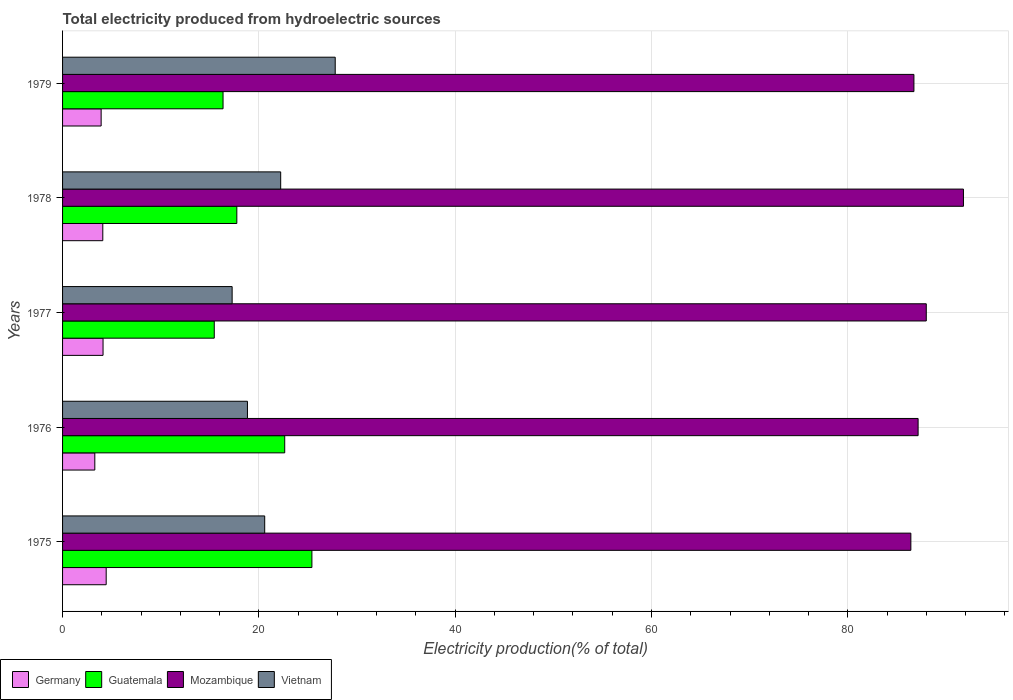Are the number of bars per tick equal to the number of legend labels?
Make the answer very short. Yes. What is the label of the 2nd group of bars from the top?
Offer a very short reply. 1978. What is the total electricity produced in Vietnam in 1975?
Keep it short and to the point. 20.59. Across all years, what is the maximum total electricity produced in Mozambique?
Provide a short and direct response. 91.78. Across all years, what is the minimum total electricity produced in Mozambique?
Give a very brief answer. 86.42. In which year was the total electricity produced in Guatemala maximum?
Offer a very short reply. 1975. In which year was the total electricity produced in Mozambique minimum?
Provide a succinct answer. 1975. What is the total total electricity produced in Vietnam in the graph?
Keep it short and to the point. 106.71. What is the difference between the total electricity produced in Vietnam in 1975 and that in 1978?
Keep it short and to the point. -1.63. What is the difference between the total electricity produced in Vietnam in 1978 and the total electricity produced in Guatemala in 1976?
Your answer should be very brief. -0.41. What is the average total electricity produced in Vietnam per year?
Your answer should be compact. 21.34. In the year 1977, what is the difference between the total electricity produced in Mozambique and total electricity produced in Guatemala?
Your response must be concise. 72.54. In how many years, is the total electricity produced in Mozambique greater than 88 %?
Ensure brevity in your answer.  1. What is the ratio of the total electricity produced in Germany in 1976 to that in 1978?
Keep it short and to the point. 0.8. Is the total electricity produced in Mozambique in 1975 less than that in 1976?
Your response must be concise. Yes. Is the difference between the total electricity produced in Mozambique in 1976 and 1978 greater than the difference between the total electricity produced in Guatemala in 1976 and 1978?
Make the answer very short. No. What is the difference between the highest and the second highest total electricity produced in Mozambique?
Offer a very short reply. 3.79. What is the difference between the highest and the lowest total electricity produced in Germany?
Offer a terse response. 1.16. Is the sum of the total electricity produced in Mozambique in 1976 and 1978 greater than the maximum total electricity produced in Vietnam across all years?
Ensure brevity in your answer.  Yes. What does the 1st bar from the top in 1977 represents?
Your answer should be compact. Vietnam. What does the 3rd bar from the bottom in 1978 represents?
Your answer should be very brief. Mozambique. Is it the case that in every year, the sum of the total electricity produced in Guatemala and total electricity produced in Vietnam is greater than the total electricity produced in Germany?
Your answer should be compact. Yes. How many bars are there?
Keep it short and to the point. 20. Are all the bars in the graph horizontal?
Provide a short and direct response. Yes. What is the difference between two consecutive major ticks on the X-axis?
Give a very brief answer. 20. Does the graph contain grids?
Offer a very short reply. Yes. How are the legend labels stacked?
Offer a very short reply. Horizontal. What is the title of the graph?
Your answer should be very brief. Total electricity produced from hydroelectric sources. What is the label or title of the X-axis?
Give a very brief answer. Electricity production(% of total). What is the Electricity production(% of total) in Germany in 1975?
Keep it short and to the point. 4.44. What is the Electricity production(% of total) of Guatemala in 1975?
Ensure brevity in your answer.  25.4. What is the Electricity production(% of total) of Mozambique in 1975?
Your answer should be compact. 86.42. What is the Electricity production(% of total) in Vietnam in 1975?
Keep it short and to the point. 20.59. What is the Electricity production(% of total) in Germany in 1976?
Ensure brevity in your answer.  3.29. What is the Electricity production(% of total) of Guatemala in 1976?
Keep it short and to the point. 22.63. What is the Electricity production(% of total) in Mozambique in 1976?
Your response must be concise. 87.16. What is the Electricity production(% of total) of Vietnam in 1976?
Provide a succinct answer. 18.84. What is the Electricity production(% of total) in Germany in 1977?
Your answer should be very brief. 4.12. What is the Electricity production(% of total) of Guatemala in 1977?
Provide a short and direct response. 15.46. What is the Electricity production(% of total) of Mozambique in 1977?
Provide a succinct answer. 87.99. What is the Electricity production(% of total) in Vietnam in 1977?
Provide a short and direct response. 17.28. What is the Electricity production(% of total) of Germany in 1978?
Provide a short and direct response. 4.1. What is the Electricity production(% of total) in Guatemala in 1978?
Provide a succinct answer. 17.75. What is the Electricity production(% of total) of Mozambique in 1978?
Give a very brief answer. 91.78. What is the Electricity production(% of total) in Vietnam in 1978?
Ensure brevity in your answer.  22.22. What is the Electricity production(% of total) of Germany in 1979?
Ensure brevity in your answer.  3.93. What is the Electricity production(% of total) of Guatemala in 1979?
Provide a succinct answer. 16.35. What is the Electricity production(% of total) of Mozambique in 1979?
Provide a succinct answer. 86.73. What is the Electricity production(% of total) in Vietnam in 1979?
Ensure brevity in your answer.  27.78. Across all years, what is the maximum Electricity production(% of total) in Germany?
Ensure brevity in your answer.  4.44. Across all years, what is the maximum Electricity production(% of total) in Guatemala?
Make the answer very short. 25.4. Across all years, what is the maximum Electricity production(% of total) of Mozambique?
Your answer should be very brief. 91.78. Across all years, what is the maximum Electricity production(% of total) of Vietnam?
Provide a short and direct response. 27.78. Across all years, what is the minimum Electricity production(% of total) of Germany?
Your answer should be compact. 3.29. Across all years, what is the minimum Electricity production(% of total) in Guatemala?
Your response must be concise. 15.46. Across all years, what is the minimum Electricity production(% of total) in Mozambique?
Keep it short and to the point. 86.42. Across all years, what is the minimum Electricity production(% of total) in Vietnam?
Ensure brevity in your answer.  17.28. What is the total Electricity production(% of total) in Germany in the graph?
Your answer should be very brief. 19.88. What is the total Electricity production(% of total) of Guatemala in the graph?
Provide a succinct answer. 97.59. What is the total Electricity production(% of total) of Mozambique in the graph?
Your answer should be very brief. 440.09. What is the total Electricity production(% of total) of Vietnam in the graph?
Make the answer very short. 106.71. What is the difference between the Electricity production(% of total) in Germany in 1975 and that in 1976?
Your answer should be very brief. 1.16. What is the difference between the Electricity production(% of total) of Guatemala in 1975 and that in 1976?
Ensure brevity in your answer.  2.77. What is the difference between the Electricity production(% of total) of Mozambique in 1975 and that in 1976?
Ensure brevity in your answer.  -0.74. What is the difference between the Electricity production(% of total) of Vietnam in 1975 and that in 1976?
Keep it short and to the point. 1.76. What is the difference between the Electricity production(% of total) of Germany in 1975 and that in 1977?
Give a very brief answer. 0.32. What is the difference between the Electricity production(% of total) in Guatemala in 1975 and that in 1977?
Offer a very short reply. 9.95. What is the difference between the Electricity production(% of total) in Mozambique in 1975 and that in 1977?
Offer a terse response. -1.57. What is the difference between the Electricity production(% of total) in Vietnam in 1975 and that in 1977?
Offer a very short reply. 3.32. What is the difference between the Electricity production(% of total) of Germany in 1975 and that in 1978?
Offer a terse response. 0.35. What is the difference between the Electricity production(% of total) of Guatemala in 1975 and that in 1978?
Ensure brevity in your answer.  7.65. What is the difference between the Electricity production(% of total) of Mozambique in 1975 and that in 1978?
Offer a very short reply. -5.36. What is the difference between the Electricity production(% of total) of Vietnam in 1975 and that in 1978?
Your answer should be compact. -1.63. What is the difference between the Electricity production(% of total) of Germany in 1975 and that in 1979?
Give a very brief answer. 0.51. What is the difference between the Electricity production(% of total) of Guatemala in 1975 and that in 1979?
Make the answer very short. 9.05. What is the difference between the Electricity production(% of total) in Mozambique in 1975 and that in 1979?
Make the answer very short. -0.31. What is the difference between the Electricity production(% of total) in Vietnam in 1975 and that in 1979?
Give a very brief answer. -7.18. What is the difference between the Electricity production(% of total) of Germany in 1976 and that in 1977?
Offer a terse response. -0.84. What is the difference between the Electricity production(% of total) of Guatemala in 1976 and that in 1977?
Make the answer very short. 7.18. What is the difference between the Electricity production(% of total) in Mozambique in 1976 and that in 1977?
Provide a succinct answer. -0.83. What is the difference between the Electricity production(% of total) of Vietnam in 1976 and that in 1977?
Ensure brevity in your answer.  1.56. What is the difference between the Electricity production(% of total) of Germany in 1976 and that in 1978?
Offer a very short reply. -0.81. What is the difference between the Electricity production(% of total) of Guatemala in 1976 and that in 1978?
Keep it short and to the point. 4.88. What is the difference between the Electricity production(% of total) of Mozambique in 1976 and that in 1978?
Ensure brevity in your answer.  -4.62. What is the difference between the Electricity production(% of total) of Vietnam in 1976 and that in 1978?
Your answer should be compact. -3.39. What is the difference between the Electricity production(% of total) in Germany in 1976 and that in 1979?
Provide a succinct answer. -0.64. What is the difference between the Electricity production(% of total) of Guatemala in 1976 and that in 1979?
Your answer should be compact. 6.28. What is the difference between the Electricity production(% of total) in Mozambique in 1976 and that in 1979?
Make the answer very short. 0.43. What is the difference between the Electricity production(% of total) of Vietnam in 1976 and that in 1979?
Ensure brevity in your answer.  -8.94. What is the difference between the Electricity production(% of total) of Germany in 1977 and that in 1978?
Your answer should be very brief. 0.03. What is the difference between the Electricity production(% of total) of Guatemala in 1977 and that in 1978?
Provide a succinct answer. -2.3. What is the difference between the Electricity production(% of total) in Mozambique in 1977 and that in 1978?
Keep it short and to the point. -3.79. What is the difference between the Electricity production(% of total) in Vietnam in 1977 and that in 1978?
Ensure brevity in your answer.  -4.95. What is the difference between the Electricity production(% of total) in Germany in 1977 and that in 1979?
Offer a very short reply. 0.19. What is the difference between the Electricity production(% of total) of Guatemala in 1977 and that in 1979?
Provide a succinct answer. -0.89. What is the difference between the Electricity production(% of total) in Mozambique in 1977 and that in 1979?
Give a very brief answer. 1.26. What is the difference between the Electricity production(% of total) in Vietnam in 1977 and that in 1979?
Your answer should be compact. -10.5. What is the difference between the Electricity production(% of total) in Germany in 1978 and that in 1979?
Your answer should be compact. 0.17. What is the difference between the Electricity production(% of total) of Guatemala in 1978 and that in 1979?
Provide a short and direct response. 1.4. What is the difference between the Electricity production(% of total) in Mozambique in 1978 and that in 1979?
Your answer should be compact. 5.05. What is the difference between the Electricity production(% of total) in Vietnam in 1978 and that in 1979?
Offer a very short reply. -5.56. What is the difference between the Electricity production(% of total) in Germany in 1975 and the Electricity production(% of total) in Guatemala in 1976?
Make the answer very short. -18.19. What is the difference between the Electricity production(% of total) in Germany in 1975 and the Electricity production(% of total) in Mozambique in 1976?
Your answer should be very brief. -82.72. What is the difference between the Electricity production(% of total) of Germany in 1975 and the Electricity production(% of total) of Vietnam in 1976?
Offer a terse response. -14.39. What is the difference between the Electricity production(% of total) in Guatemala in 1975 and the Electricity production(% of total) in Mozambique in 1976?
Offer a very short reply. -61.76. What is the difference between the Electricity production(% of total) of Guatemala in 1975 and the Electricity production(% of total) of Vietnam in 1976?
Provide a succinct answer. 6.57. What is the difference between the Electricity production(% of total) in Mozambique in 1975 and the Electricity production(% of total) in Vietnam in 1976?
Your response must be concise. 67.59. What is the difference between the Electricity production(% of total) of Germany in 1975 and the Electricity production(% of total) of Guatemala in 1977?
Offer a terse response. -11.01. What is the difference between the Electricity production(% of total) in Germany in 1975 and the Electricity production(% of total) in Mozambique in 1977?
Offer a very short reply. -83.55. What is the difference between the Electricity production(% of total) of Germany in 1975 and the Electricity production(% of total) of Vietnam in 1977?
Your answer should be compact. -12.83. What is the difference between the Electricity production(% of total) of Guatemala in 1975 and the Electricity production(% of total) of Mozambique in 1977?
Make the answer very short. -62.59. What is the difference between the Electricity production(% of total) of Guatemala in 1975 and the Electricity production(% of total) of Vietnam in 1977?
Your answer should be very brief. 8.13. What is the difference between the Electricity production(% of total) of Mozambique in 1975 and the Electricity production(% of total) of Vietnam in 1977?
Make the answer very short. 69.15. What is the difference between the Electricity production(% of total) of Germany in 1975 and the Electricity production(% of total) of Guatemala in 1978?
Offer a terse response. -13.31. What is the difference between the Electricity production(% of total) in Germany in 1975 and the Electricity production(% of total) in Mozambique in 1978?
Provide a short and direct response. -87.34. What is the difference between the Electricity production(% of total) of Germany in 1975 and the Electricity production(% of total) of Vietnam in 1978?
Make the answer very short. -17.78. What is the difference between the Electricity production(% of total) of Guatemala in 1975 and the Electricity production(% of total) of Mozambique in 1978?
Make the answer very short. -66.38. What is the difference between the Electricity production(% of total) in Guatemala in 1975 and the Electricity production(% of total) in Vietnam in 1978?
Ensure brevity in your answer.  3.18. What is the difference between the Electricity production(% of total) in Mozambique in 1975 and the Electricity production(% of total) in Vietnam in 1978?
Provide a short and direct response. 64.2. What is the difference between the Electricity production(% of total) of Germany in 1975 and the Electricity production(% of total) of Guatemala in 1979?
Give a very brief answer. -11.91. What is the difference between the Electricity production(% of total) in Germany in 1975 and the Electricity production(% of total) in Mozambique in 1979?
Ensure brevity in your answer.  -82.29. What is the difference between the Electricity production(% of total) in Germany in 1975 and the Electricity production(% of total) in Vietnam in 1979?
Offer a terse response. -23.33. What is the difference between the Electricity production(% of total) in Guatemala in 1975 and the Electricity production(% of total) in Mozambique in 1979?
Your answer should be very brief. -61.33. What is the difference between the Electricity production(% of total) of Guatemala in 1975 and the Electricity production(% of total) of Vietnam in 1979?
Provide a succinct answer. -2.38. What is the difference between the Electricity production(% of total) of Mozambique in 1975 and the Electricity production(% of total) of Vietnam in 1979?
Provide a succinct answer. 58.65. What is the difference between the Electricity production(% of total) in Germany in 1976 and the Electricity production(% of total) in Guatemala in 1977?
Your answer should be very brief. -12.17. What is the difference between the Electricity production(% of total) in Germany in 1976 and the Electricity production(% of total) in Mozambique in 1977?
Ensure brevity in your answer.  -84.71. What is the difference between the Electricity production(% of total) in Germany in 1976 and the Electricity production(% of total) in Vietnam in 1977?
Give a very brief answer. -13.99. What is the difference between the Electricity production(% of total) in Guatemala in 1976 and the Electricity production(% of total) in Mozambique in 1977?
Provide a short and direct response. -65.36. What is the difference between the Electricity production(% of total) in Guatemala in 1976 and the Electricity production(% of total) in Vietnam in 1977?
Keep it short and to the point. 5.36. What is the difference between the Electricity production(% of total) of Mozambique in 1976 and the Electricity production(% of total) of Vietnam in 1977?
Offer a terse response. 69.89. What is the difference between the Electricity production(% of total) of Germany in 1976 and the Electricity production(% of total) of Guatemala in 1978?
Provide a short and direct response. -14.47. What is the difference between the Electricity production(% of total) of Germany in 1976 and the Electricity production(% of total) of Mozambique in 1978?
Provide a short and direct response. -88.49. What is the difference between the Electricity production(% of total) of Germany in 1976 and the Electricity production(% of total) of Vietnam in 1978?
Make the answer very short. -18.94. What is the difference between the Electricity production(% of total) of Guatemala in 1976 and the Electricity production(% of total) of Mozambique in 1978?
Give a very brief answer. -69.15. What is the difference between the Electricity production(% of total) of Guatemala in 1976 and the Electricity production(% of total) of Vietnam in 1978?
Keep it short and to the point. 0.41. What is the difference between the Electricity production(% of total) in Mozambique in 1976 and the Electricity production(% of total) in Vietnam in 1978?
Give a very brief answer. 64.94. What is the difference between the Electricity production(% of total) of Germany in 1976 and the Electricity production(% of total) of Guatemala in 1979?
Provide a short and direct response. -13.06. What is the difference between the Electricity production(% of total) of Germany in 1976 and the Electricity production(% of total) of Mozambique in 1979?
Provide a succinct answer. -83.45. What is the difference between the Electricity production(% of total) in Germany in 1976 and the Electricity production(% of total) in Vietnam in 1979?
Offer a very short reply. -24.49. What is the difference between the Electricity production(% of total) in Guatemala in 1976 and the Electricity production(% of total) in Mozambique in 1979?
Keep it short and to the point. -64.1. What is the difference between the Electricity production(% of total) of Guatemala in 1976 and the Electricity production(% of total) of Vietnam in 1979?
Make the answer very short. -5.15. What is the difference between the Electricity production(% of total) in Mozambique in 1976 and the Electricity production(% of total) in Vietnam in 1979?
Make the answer very short. 59.38. What is the difference between the Electricity production(% of total) in Germany in 1977 and the Electricity production(% of total) in Guatemala in 1978?
Provide a short and direct response. -13.63. What is the difference between the Electricity production(% of total) of Germany in 1977 and the Electricity production(% of total) of Mozambique in 1978?
Make the answer very short. -87.66. What is the difference between the Electricity production(% of total) in Germany in 1977 and the Electricity production(% of total) in Vietnam in 1978?
Make the answer very short. -18.1. What is the difference between the Electricity production(% of total) in Guatemala in 1977 and the Electricity production(% of total) in Mozambique in 1978?
Keep it short and to the point. -76.33. What is the difference between the Electricity production(% of total) of Guatemala in 1977 and the Electricity production(% of total) of Vietnam in 1978?
Provide a short and direct response. -6.77. What is the difference between the Electricity production(% of total) of Mozambique in 1977 and the Electricity production(% of total) of Vietnam in 1978?
Give a very brief answer. 65.77. What is the difference between the Electricity production(% of total) of Germany in 1977 and the Electricity production(% of total) of Guatemala in 1979?
Your answer should be compact. -12.22. What is the difference between the Electricity production(% of total) in Germany in 1977 and the Electricity production(% of total) in Mozambique in 1979?
Make the answer very short. -82.61. What is the difference between the Electricity production(% of total) of Germany in 1977 and the Electricity production(% of total) of Vietnam in 1979?
Offer a very short reply. -23.65. What is the difference between the Electricity production(% of total) of Guatemala in 1977 and the Electricity production(% of total) of Mozambique in 1979?
Keep it short and to the point. -71.28. What is the difference between the Electricity production(% of total) in Guatemala in 1977 and the Electricity production(% of total) in Vietnam in 1979?
Ensure brevity in your answer.  -12.32. What is the difference between the Electricity production(% of total) of Mozambique in 1977 and the Electricity production(% of total) of Vietnam in 1979?
Your answer should be compact. 60.22. What is the difference between the Electricity production(% of total) of Germany in 1978 and the Electricity production(% of total) of Guatemala in 1979?
Offer a terse response. -12.25. What is the difference between the Electricity production(% of total) of Germany in 1978 and the Electricity production(% of total) of Mozambique in 1979?
Ensure brevity in your answer.  -82.64. What is the difference between the Electricity production(% of total) of Germany in 1978 and the Electricity production(% of total) of Vietnam in 1979?
Keep it short and to the point. -23.68. What is the difference between the Electricity production(% of total) of Guatemala in 1978 and the Electricity production(% of total) of Mozambique in 1979?
Your response must be concise. -68.98. What is the difference between the Electricity production(% of total) in Guatemala in 1978 and the Electricity production(% of total) in Vietnam in 1979?
Offer a terse response. -10.02. What is the difference between the Electricity production(% of total) in Mozambique in 1978 and the Electricity production(% of total) in Vietnam in 1979?
Offer a terse response. 64. What is the average Electricity production(% of total) in Germany per year?
Offer a terse response. 3.98. What is the average Electricity production(% of total) in Guatemala per year?
Provide a short and direct response. 19.52. What is the average Electricity production(% of total) in Mozambique per year?
Offer a very short reply. 88.02. What is the average Electricity production(% of total) of Vietnam per year?
Give a very brief answer. 21.34. In the year 1975, what is the difference between the Electricity production(% of total) of Germany and Electricity production(% of total) of Guatemala?
Give a very brief answer. -20.96. In the year 1975, what is the difference between the Electricity production(% of total) of Germany and Electricity production(% of total) of Mozambique?
Your answer should be compact. -81.98. In the year 1975, what is the difference between the Electricity production(% of total) in Germany and Electricity production(% of total) in Vietnam?
Your response must be concise. -16.15. In the year 1975, what is the difference between the Electricity production(% of total) in Guatemala and Electricity production(% of total) in Mozambique?
Offer a very short reply. -61.02. In the year 1975, what is the difference between the Electricity production(% of total) in Guatemala and Electricity production(% of total) in Vietnam?
Your answer should be compact. 4.81. In the year 1975, what is the difference between the Electricity production(% of total) in Mozambique and Electricity production(% of total) in Vietnam?
Offer a very short reply. 65.83. In the year 1976, what is the difference between the Electricity production(% of total) in Germany and Electricity production(% of total) in Guatemala?
Your response must be concise. -19.35. In the year 1976, what is the difference between the Electricity production(% of total) of Germany and Electricity production(% of total) of Mozambique?
Give a very brief answer. -83.88. In the year 1976, what is the difference between the Electricity production(% of total) of Germany and Electricity production(% of total) of Vietnam?
Your answer should be compact. -15.55. In the year 1976, what is the difference between the Electricity production(% of total) of Guatemala and Electricity production(% of total) of Mozambique?
Give a very brief answer. -64.53. In the year 1976, what is the difference between the Electricity production(% of total) of Guatemala and Electricity production(% of total) of Vietnam?
Your answer should be very brief. 3.8. In the year 1976, what is the difference between the Electricity production(% of total) in Mozambique and Electricity production(% of total) in Vietnam?
Your answer should be compact. 68.32. In the year 1977, what is the difference between the Electricity production(% of total) in Germany and Electricity production(% of total) in Guatemala?
Ensure brevity in your answer.  -11.33. In the year 1977, what is the difference between the Electricity production(% of total) in Germany and Electricity production(% of total) in Mozambique?
Offer a very short reply. -83.87. In the year 1977, what is the difference between the Electricity production(% of total) of Germany and Electricity production(% of total) of Vietnam?
Offer a terse response. -13.15. In the year 1977, what is the difference between the Electricity production(% of total) of Guatemala and Electricity production(% of total) of Mozambique?
Keep it short and to the point. -72.54. In the year 1977, what is the difference between the Electricity production(% of total) in Guatemala and Electricity production(% of total) in Vietnam?
Make the answer very short. -1.82. In the year 1977, what is the difference between the Electricity production(% of total) in Mozambique and Electricity production(% of total) in Vietnam?
Provide a short and direct response. 70.72. In the year 1978, what is the difference between the Electricity production(% of total) of Germany and Electricity production(% of total) of Guatemala?
Your answer should be compact. -13.66. In the year 1978, what is the difference between the Electricity production(% of total) in Germany and Electricity production(% of total) in Mozambique?
Offer a very short reply. -87.68. In the year 1978, what is the difference between the Electricity production(% of total) of Germany and Electricity production(% of total) of Vietnam?
Your response must be concise. -18.12. In the year 1978, what is the difference between the Electricity production(% of total) of Guatemala and Electricity production(% of total) of Mozambique?
Provide a short and direct response. -74.03. In the year 1978, what is the difference between the Electricity production(% of total) of Guatemala and Electricity production(% of total) of Vietnam?
Your answer should be compact. -4.47. In the year 1978, what is the difference between the Electricity production(% of total) of Mozambique and Electricity production(% of total) of Vietnam?
Your answer should be very brief. 69.56. In the year 1979, what is the difference between the Electricity production(% of total) in Germany and Electricity production(% of total) in Guatemala?
Your answer should be very brief. -12.42. In the year 1979, what is the difference between the Electricity production(% of total) in Germany and Electricity production(% of total) in Mozambique?
Provide a short and direct response. -82.8. In the year 1979, what is the difference between the Electricity production(% of total) in Germany and Electricity production(% of total) in Vietnam?
Your answer should be compact. -23.85. In the year 1979, what is the difference between the Electricity production(% of total) of Guatemala and Electricity production(% of total) of Mozambique?
Offer a very short reply. -70.39. In the year 1979, what is the difference between the Electricity production(% of total) of Guatemala and Electricity production(% of total) of Vietnam?
Provide a succinct answer. -11.43. In the year 1979, what is the difference between the Electricity production(% of total) of Mozambique and Electricity production(% of total) of Vietnam?
Keep it short and to the point. 58.96. What is the ratio of the Electricity production(% of total) of Germany in 1975 to that in 1976?
Give a very brief answer. 1.35. What is the ratio of the Electricity production(% of total) of Guatemala in 1975 to that in 1976?
Your response must be concise. 1.12. What is the ratio of the Electricity production(% of total) in Mozambique in 1975 to that in 1976?
Your response must be concise. 0.99. What is the ratio of the Electricity production(% of total) of Vietnam in 1975 to that in 1976?
Provide a succinct answer. 1.09. What is the ratio of the Electricity production(% of total) of Germany in 1975 to that in 1977?
Provide a short and direct response. 1.08. What is the ratio of the Electricity production(% of total) of Guatemala in 1975 to that in 1977?
Make the answer very short. 1.64. What is the ratio of the Electricity production(% of total) of Mozambique in 1975 to that in 1977?
Your answer should be very brief. 0.98. What is the ratio of the Electricity production(% of total) in Vietnam in 1975 to that in 1977?
Your answer should be very brief. 1.19. What is the ratio of the Electricity production(% of total) of Germany in 1975 to that in 1978?
Offer a very short reply. 1.08. What is the ratio of the Electricity production(% of total) of Guatemala in 1975 to that in 1978?
Ensure brevity in your answer.  1.43. What is the ratio of the Electricity production(% of total) in Mozambique in 1975 to that in 1978?
Your answer should be compact. 0.94. What is the ratio of the Electricity production(% of total) of Vietnam in 1975 to that in 1978?
Your answer should be compact. 0.93. What is the ratio of the Electricity production(% of total) in Germany in 1975 to that in 1979?
Make the answer very short. 1.13. What is the ratio of the Electricity production(% of total) of Guatemala in 1975 to that in 1979?
Give a very brief answer. 1.55. What is the ratio of the Electricity production(% of total) in Mozambique in 1975 to that in 1979?
Your response must be concise. 1. What is the ratio of the Electricity production(% of total) in Vietnam in 1975 to that in 1979?
Your answer should be compact. 0.74. What is the ratio of the Electricity production(% of total) in Germany in 1976 to that in 1977?
Your answer should be very brief. 0.8. What is the ratio of the Electricity production(% of total) of Guatemala in 1976 to that in 1977?
Your response must be concise. 1.46. What is the ratio of the Electricity production(% of total) in Mozambique in 1976 to that in 1977?
Your answer should be compact. 0.99. What is the ratio of the Electricity production(% of total) in Vietnam in 1976 to that in 1977?
Offer a very short reply. 1.09. What is the ratio of the Electricity production(% of total) of Germany in 1976 to that in 1978?
Provide a short and direct response. 0.8. What is the ratio of the Electricity production(% of total) in Guatemala in 1976 to that in 1978?
Ensure brevity in your answer.  1.27. What is the ratio of the Electricity production(% of total) of Mozambique in 1976 to that in 1978?
Offer a very short reply. 0.95. What is the ratio of the Electricity production(% of total) of Vietnam in 1976 to that in 1978?
Keep it short and to the point. 0.85. What is the ratio of the Electricity production(% of total) in Germany in 1976 to that in 1979?
Offer a terse response. 0.84. What is the ratio of the Electricity production(% of total) in Guatemala in 1976 to that in 1979?
Provide a succinct answer. 1.38. What is the ratio of the Electricity production(% of total) of Mozambique in 1976 to that in 1979?
Provide a short and direct response. 1. What is the ratio of the Electricity production(% of total) in Vietnam in 1976 to that in 1979?
Your answer should be compact. 0.68. What is the ratio of the Electricity production(% of total) of Germany in 1977 to that in 1978?
Make the answer very short. 1.01. What is the ratio of the Electricity production(% of total) of Guatemala in 1977 to that in 1978?
Give a very brief answer. 0.87. What is the ratio of the Electricity production(% of total) of Mozambique in 1977 to that in 1978?
Ensure brevity in your answer.  0.96. What is the ratio of the Electricity production(% of total) in Vietnam in 1977 to that in 1978?
Offer a very short reply. 0.78. What is the ratio of the Electricity production(% of total) of Germany in 1977 to that in 1979?
Offer a very short reply. 1.05. What is the ratio of the Electricity production(% of total) of Guatemala in 1977 to that in 1979?
Provide a succinct answer. 0.95. What is the ratio of the Electricity production(% of total) of Mozambique in 1977 to that in 1979?
Make the answer very short. 1.01. What is the ratio of the Electricity production(% of total) of Vietnam in 1977 to that in 1979?
Ensure brevity in your answer.  0.62. What is the ratio of the Electricity production(% of total) of Germany in 1978 to that in 1979?
Your answer should be compact. 1.04. What is the ratio of the Electricity production(% of total) in Guatemala in 1978 to that in 1979?
Your answer should be compact. 1.09. What is the ratio of the Electricity production(% of total) of Mozambique in 1978 to that in 1979?
Offer a terse response. 1.06. What is the ratio of the Electricity production(% of total) of Vietnam in 1978 to that in 1979?
Ensure brevity in your answer.  0.8. What is the difference between the highest and the second highest Electricity production(% of total) of Germany?
Ensure brevity in your answer.  0.32. What is the difference between the highest and the second highest Electricity production(% of total) of Guatemala?
Your answer should be compact. 2.77. What is the difference between the highest and the second highest Electricity production(% of total) of Mozambique?
Offer a terse response. 3.79. What is the difference between the highest and the second highest Electricity production(% of total) in Vietnam?
Ensure brevity in your answer.  5.56. What is the difference between the highest and the lowest Electricity production(% of total) in Germany?
Ensure brevity in your answer.  1.16. What is the difference between the highest and the lowest Electricity production(% of total) of Guatemala?
Ensure brevity in your answer.  9.95. What is the difference between the highest and the lowest Electricity production(% of total) in Mozambique?
Provide a succinct answer. 5.36. What is the difference between the highest and the lowest Electricity production(% of total) of Vietnam?
Provide a short and direct response. 10.5. 